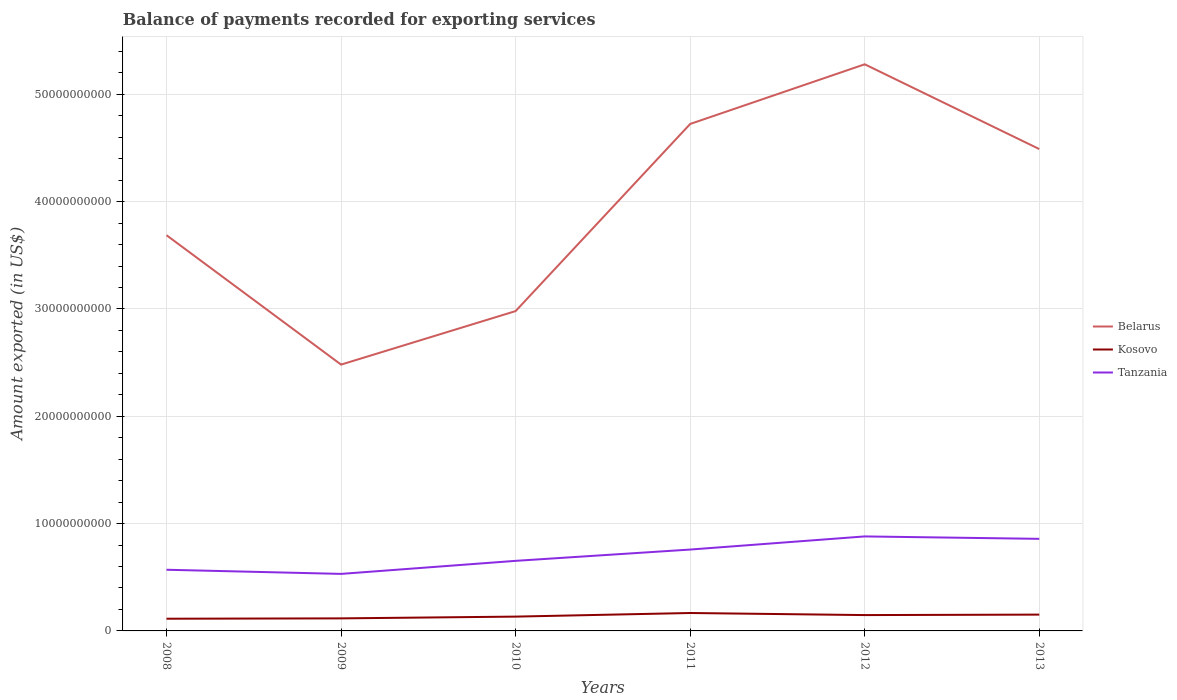Is the number of lines equal to the number of legend labels?
Ensure brevity in your answer.  Yes. Across all years, what is the maximum amount exported in Kosovo?
Ensure brevity in your answer.  1.14e+09. In which year was the amount exported in Kosovo maximum?
Your answer should be very brief. 2008. What is the total amount exported in Belarus in the graph?
Provide a succinct answer. 2.34e+09. What is the difference between the highest and the second highest amount exported in Kosovo?
Make the answer very short. 5.33e+08. What is the difference between the highest and the lowest amount exported in Kosovo?
Ensure brevity in your answer.  3. Is the amount exported in Belarus strictly greater than the amount exported in Tanzania over the years?
Offer a terse response. No. How many lines are there?
Make the answer very short. 3. How many years are there in the graph?
Keep it short and to the point. 6. Does the graph contain any zero values?
Your response must be concise. No. Does the graph contain grids?
Provide a succinct answer. Yes. Where does the legend appear in the graph?
Keep it short and to the point. Center right. How many legend labels are there?
Provide a short and direct response. 3. How are the legend labels stacked?
Offer a very short reply. Vertical. What is the title of the graph?
Your answer should be compact. Balance of payments recorded for exporting services. What is the label or title of the X-axis?
Ensure brevity in your answer.  Years. What is the label or title of the Y-axis?
Your response must be concise. Amount exported (in US$). What is the Amount exported (in US$) in Belarus in 2008?
Ensure brevity in your answer.  3.69e+1. What is the Amount exported (in US$) in Kosovo in 2008?
Provide a short and direct response. 1.14e+09. What is the Amount exported (in US$) of Tanzania in 2008?
Your answer should be very brief. 5.70e+09. What is the Amount exported (in US$) in Belarus in 2009?
Provide a succinct answer. 2.48e+1. What is the Amount exported (in US$) in Kosovo in 2009?
Make the answer very short. 1.17e+09. What is the Amount exported (in US$) in Tanzania in 2009?
Offer a terse response. 5.31e+09. What is the Amount exported (in US$) in Belarus in 2010?
Your answer should be very brief. 2.98e+1. What is the Amount exported (in US$) of Kosovo in 2010?
Offer a terse response. 1.33e+09. What is the Amount exported (in US$) in Tanzania in 2010?
Provide a short and direct response. 6.53e+09. What is the Amount exported (in US$) in Belarus in 2011?
Provide a short and direct response. 4.72e+1. What is the Amount exported (in US$) in Kosovo in 2011?
Your answer should be compact. 1.67e+09. What is the Amount exported (in US$) of Tanzania in 2011?
Provide a short and direct response. 7.58e+09. What is the Amount exported (in US$) in Belarus in 2012?
Keep it short and to the point. 5.28e+1. What is the Amount exported (in US$) in Kosovo in 2012?
Offer a very short reply. 1.48e+09. What is the Amount exported (in US$) of Tanzania in 2012?
Offer a terse response. 8.81e+09. What is the Amount exported (in US$) in Belarus in 2013?
Ensure brevity in your answer.  4.49e+1. What is the Amount exported (in US$) in Kosovo in 2013?
Ensure brevity in your answer.  1.52e+09. What is the Amount exported (in US$) of Tanzania in 2013?
Ensure brevity in your answer.  8.58e+09. Across all years, what is the maximum Amount exported (in US$) of Belarus?
Your answer should be very brief. 5.28e+1. Across all years, what is the maximum Amount exported (in US$) of Kosovo?
Your response must be concise. 1.67e+09. Across all years, what is the maximum Amount exported (in US$) in Tanzania?
Your answer should be compact. 8.81e+09. Across all years, what is the minimum Amount exported (in US$) of Belarus?
Offer a very short reply. 2.48e+1. Across all years, what is the minimum Amount exported (in US$) of Kosovo?
Make the answer very short. 1.14e+09. Across all years, what is the minimum Amount exported (in US$) in Tanzania?
Make the answer very short. 5.31e+09. What is the total Amount exported (in US$) in Belarus in the graph?
Your answer should be compact. 2.36e+11. What is the total Amount exported (in US$) of Kosovo in the graph?
Make the answer very short. 8.31e+09. What is the total Amount exported (in US$) in Tanzania in the graph?
Offer a very short reply. 4.25e+1. What is the difference between the Amount exported (in US$) in Belarus in 2008 and that in 2009?
Your response must be concise. 1.21e+1. What is the difference between the Amount exported (in US$) of Kosovo in 2008 and that in 2009?
Ensure brevity in your answer.  -3.21e+07. What is the difference between the Amount exported (in US$) of Tanzania in 2008 and that in 2009?
Make the answer very short. 3.86e+08. What is the difference between the Amount exported (in US$) of Belarus in 2008 and that in 2010?
Your answer should be very brief. 7.07e+09. What is the difference between the Amount exported (in US$) of Kosovo in 2008 and that in 2010?
Your response must be concise. -1.95e+08. What is the difference between the Amount exported (in US$) of Tanzania in 2008 and that in 2010?
Provide a succinct answer. -8.30e+08. What is the difference between the Amount exported (in US$) in Belarus in 2008 and that in 2011?
Make the answer very short. -1.04e+1. What is the difference between the Amount exported (in US$) of Kosovo in 2008 and that in 2011?
Your response must be concise. -5.33e+08. What is the difference between the Amount exported (in US$) in Tanzania in 2008 and that in 2011?
Ensure brevity in your answer.  -1.88e+09. What is the difference between the Amount exported (in US$) of Belarus in 2008 and that in 2012?
Give a very brief answer. -1.59e+1. What is the difference between the Amount exported (in US$) in Kosovo in 2008 and that in 2012?
Make the answer very short. -3.39e+08. What is the difference between the Amount exported (in US$) in Tanzania in 2008 and that in 2012?
Your response must be concise. -3.11e+09. What is the difference between the Amount exported (in US$) in Belarus in 2008 and that in 2013?
Give a very brief answer. -8.03e+09. What is the difference between the Amount exported (in US$) in Kosovo in 2008 and that in 2013?
Your response must be concise. -3.82e+08. What is the difference between the Amount exported (in US$) of Tanzania in 2008 and that in 2013?
Provide a short and direct response. -2.88e+09. What is the difference between the Amount exported (in US$) of Belarus in 2009 and that in 2010?
Provide a short and direct response. -4.99e+09. What is the difference between the Amount exported (in US$) of Kosovo in 2009 and that in 2010?
Provide a succinct answer. -1.63e+08. What is the difference between the Amount exported (in US$) of Tanzania in 2009 and that in 2010?
Ensure brevity in your answer.  -1.22e+09. What is the difference between the Amount exported (in US$) in Belarus in 2009 and that in 2011?
Your response must be concise. -2.24e+1. What is the difference between the Amount exported (in US$) of Kosovo in 2009 and that in 2011?
Provide a succinct answer. -5.01e+08. What is the difference between the Amount exported (in US$) in Tanzania in 2009 and that in 2011?
Give a very brief answer. -2.27e+09. What is the difference between the Amount exported (in US$) in Belarus in 2009 and that in 2012?
Your answer should be very brief. -2.80e+1. What is the difference between the Amount exported (in US$) in Kosovo in 2009 and that in 2012?
Your response must be concise. -3.07e+08. What is the difference between the Amount exported (in US$) of Tanzania in 2009 and that in 2012?
Give a very brief answer. -3.49e+09. What is the difference between the Amount exported (in US$) of Belarus in 2009 and that in 2013?
Give a very brief answer. -2.01e+1. What is the difference between the Amount exported (in US$) in Kosovo in 2009 and that in 2013?
Offer a terse response. -3.50e+08. What is the difference between the Amount exported (in US$) in Tanzania in 2009 and that in 2013?
Keep it short and to the point. -3.27e+09. What is the difference between the Amount exported (in US$) of Belarus in 2010 and that in 2011?
Your answer should be compact. -1.74e+1. What is the difference between the Amount exported (in US$) in Kosovo in 2010 and that in 2011?
Your answer should be very brief. -3.37e+08. What is the difference between the Amount exported (in US$) in Tanzania in 2010 and that in 2011?
Provide a succinct answer. -1.05e+09. What is the difference between the Amount exported (in US$) in Belarus in 2010 and that in 2012?
Ensure brevity in your answer.  -2.30e+1. What is the difference between the Amount exported (in US$) of Kosovo in 2010 and that in 2012?
Offer a very short reply. -1.44e+08. What is the difference between the Amount exported (in US$) in Tanzania in 2010 and that in 2012?
Your answer should be compact. -2.28e+09. What is the difference between the Amount exported (in US$) in Belarus in 2010 and that in 2013?
Ensure brevity in your answer.  -1.51e+1. What is the difference between the Amount exported (in US$) of Kosovo in 2010 and that in 2013?
Give a very brief answer. -1.87e+08. What is the difference between the Amount exported (in US$) of Tanzania in 2010 and that in 2013?
Your answer should be compact. -2.05e+09. What is the difference between the Amount exported (in US$) of Belarus in 2011 and that in 2012?
Your answer should be compact. -5.56e+09. What is the difference between the Amount exported (in US$) of Kosovo in 2011 and that in 2012?
Your answer should be very brief. 1.93e+08. What is the difference between the Amount exported (in US$) of Tanzania in 2011 and that in 2012?
Make the answer very short. -1.22e+09. What is the difference between the Amount exported (in US$) of Belarus in 2011 and that in 2013?
Ensure brevity in your answer.  2.34e+09. What is the difference between the Amount exported (in US$) of Kosovo in 2011 and that in 2013?
Make the answer very short. 1.50e+08. What is the difference between the Amount exported (in US$) of Tanzania in 2011 and that in 2013?
Provide a succinct answer. -9.98e+08. What is the difference between the Amount exported (in US$) in Belarus in 2012 and that in 2013?
Ensure brevity in your answer.  7.90e+09. What is the difference between the Amount exported (in US$) of Kosovo in 2012 and that in 2013?
Your answer should be compact. -4.29e+07. What is the difference between the Amount exported (in US$) in Tanzania in 2012 and that in 2013?
Ensure brevity in your answer.  2.26e+08. What is the difference between the Amount exported (in US$) in Belarus in 2008 and the Amount exported (in US$) in Kosovo in 2009?
Offer a very short reply. 3.57e+1. What is the difference between the Amount exported (in US$) in Belarus in 2008 and the Amount exported (in US$) in Tanzania in 2009?
Ensure brevity in your answer.  3.16e+1. What is the difference between the Amount exported (in US$) of Kosovo in 2008 and the Amount exported (in US$) of Tanzania in 2009?
Provide a succinct answer. -4.18e+09. What is the difference between the Amount exported (in US$) in Belarus in 2008 and the Amount exported (in US$) in Kosovo in 2010?
Offer a very short reply. 3.55e+1. What is the difference between the Amount exported (in US$) in Belarus in 2008 and the Amount exported (in US$) in Tanzania in 2010?
Provide a short and direct response. 3.03e+1. What is the difference between the Amount exported (in US$) in Kosovo in 2008 and the Amount exported (in US$) in Tanzania in 2010?
Provide a succinct answer. -5.39e+09. What is the difference between the Amount exported (in US$) of Belarus in 2008 and the Amount exported (in US$) of Kosovo in 2011?
Make the answer very short. 3.52e+1. What is the difference between the Amount exported (in US$) in Belarus in 2008 and the Amount exported (in US$) in Tanzania in 2011?
Your answer should be very brief. 2.93e+1. What is the difference between the Amount exported (in US$) of Kosovo in 2008 and the Amount exported (in US$) of Tanzania in 2011?
Your answer should be compact. -6.44e+09. What is the difference between the Amount exported (in US$) of Belarus in 2008 and the Amount exported (in US$) of Kosovo in 2012?
Make the answer very short. 3.54e+1. What is the difference between the Amount exported (in US$) in Belarus in 2008 and the Amount exported (in US$) in Tanzania in 2012?
Give a very brief answer. 2.81e+1. What is the difference between the Amount exported (in US$) in Kosovo in 2008 and the Amount exported (in US$) in Tanzania in 2012?
Provide a short and direct response. -7.67e+09. What is the difference between the Amount exported (in US$) in Belarus in 2008 and the Amount exported (in US$) in Kosovo in 2013?
Make the answer very short. 3.54e+1. What is the difference between the Amount exported (in US$) of Belarus in 2008 and the Amount exported (in US$) of Tanzania in 2013?
Keep it short and to the point. 2.83e+1. What is the difference between the Amount exported (in US$) of Kosovo in 2008 and the Amount exported (in US$) of Tanzania in 2013?
Provide a short and direct response. -7.44e+09. What is the difference between the Amount exported (in US$) of Belarus in 2009 and the Amount exported (in US$) of Kosovo in 2010?
Make the answer very short. 2.35e+1. What is the difference between the Amount exported (in US$) in Belarus in 2009 and the Amount exported (in US$) in Tanzania in 2010?
Offer a very short reply. 1.83e+1. What is the difference between the Amount exported (in US$) of Kosovo in 2009 and the Amount exported (in US$) of Tanzania in 2010?
Offer a terse response. -5.36e+09. What is the difference between the Amount exported (in US$) of Belarus in 2009 and the Amount exported (in US$) of Kosovo in 2011?
Give a very brief answer. 2.31e+1. What is the difference between the Amount exported (in US$) of Belarus in 2009 and the Amount exported (in US$) of Tanzania in 2011?
Ensure brevity in your answer.  1.72e+1. What is the difference between the Amount exported (in US$) in Kosovo in 2009 and the Amount exported (in US$) in Tanzania in 2011?
Keep it short and to the point. -6.41e+09. What is the difference between the Amount exported (in US$) in Belarus in 2009 and the Amount exported (in US$) in Kosovo in 2012?
Your answer should be very brief. 2.33e+1. What is the difference between the Amount exported (in US$) of Belarus in 2009 and the Amount exported (in US$) of Tanzania in 2012?
Ensure brevity in your answer.  1.60e+1. What is the difference between the Amount exported (in US$) in Kosovo in 2009 and the Amount exported (in US$) in Tanzania in 2012?
Give a very brief answer. -7.64e+09. What is the difference between the Amount exported (in US$) in Belarus in 2009 and the Amount exported (in US$) in Kosovo in 2013?
Ensure brevity in your answer.  2.33e+1. What is the difference between the Amount exported (in US$) of Belarus in 2009 and the Amount exported (in US$) of Tanzania in 2013?
Provide a succinct answer. 1.62e+1. What is the difference between the Amount exported (in US$) in Kosovo in 2009 and the Amount exported (in US$) in Tanzania in 2013?
Your response must be concise. -7.41e+09. What is the difference between the Amount exported (in US$) of Belarus in 2010 and the Amount exported (in US$) of Kosovo in 2011?
Make the answer very short. 2.81e+1. What is the difference between the Amount exported (in US$) in Belarus in 2010 and the Amount exported (in US$) in Tanzania in 2011?
Your answer should be compact. 2.22e+1. What is the difference between the Amount exported (in US$) in Kosovo in 2010 and the Amount exported (in US$) in Tanzania in 2011?
Your answer should be compact. -6.25e+09. What is the difference between the Amount exported (in US$) in Belarus in 2010 and the Amount exported (in US$) in Kosovo in 2012?
Give a very brief answer. 2.83e+1. What is the difference between the Amount exported (in US$) of Belarus in 2010 and the Amount exported (in US$) of Tanzania in 2012?
Your answer should be compact. 2.10e+1. What is the difference between the Amount exported (in US$) of Kosovo in 2010 and the Amount exported (in US$) of Tanzania in 2012?
Make the answer very short. -7.47e+09. What is the difference between the Amount exported (in US$) in Belarus in 2010 and the Amount exported (in US$) in Kosovo in 2013?
Your answer should be very brief. 2.83e+1. What is the difference between the Amount exported (in US$) of Belarus in 2010 and the Amount exported (in US$) of Tanzania in 2013?
Offer a terse response. 2.12e+1. What is the difference between the Amount exported (in US$) in Kosovo in 2010 and the Amount exported (in US$) in Tanzania in 2013?
Offer a terse response. -7.25e+09. What is the difference between the Amount exported (in US$) in Belarus in 2011 and the Amount exported (in US$) in Kosovo in 2012?
Your response must be concise. 4.58e+1. What is the difference between the Amount exported (in US$) in Belarus in 2011 and the Amount exported (in US$) in Tanzania in 2012?
Ensure brevity in your answer.  3.84e+1. What is the difference between the Amount exported (in US$) of Kosovo in 2011 and the Amount exported (in US$) of Tanzania in 2012?
Keep it short and to the point. -7.14e+09. What is the difference between the Amount exported (in US$) in Belarus in 2011 and the Amount exported (in US$) in Kosovo in 2013?
Offer a very short reply. 4.57e+1. What is the difference between the Amount exported (in US$) in Belarus in 2011 and the Amount exported (in US$) in Tanzania in 2013?
Offer a terse response. 3.87e+1. What is the difference between the Amount exported (in US$) of Kosovo in 2011 and the Amount exported (in US$) of Tanzania in 2013?
Your response must be concise. -6.91e+09. What is the difference between the Amount exported (in US$) of Belarus in 2012 and the Amount exported (in US$) of Kosovo in 2013?
Make the answer very short. 5.13e+1. What is the difference between the Amount exported (in US$) of Belarus in 2012 and the Amount exported (in US$) of Tanzania in 2013?
Your response must be concise. 4.42e+1. What is the difference between the Amount exported (in US$) in Kosovo in 2012 and the Amount exported (in US$) in Tanzania in 2013?
Your response must be concise. -7.10e+09. What is the average Amount exported (in US$) in Belarus per year?
Make the answer very short. 3.94e+1. What is the average Amount exported (in US$) in Kosovo per year?
Your answer should be compact. 1.38e+09. What is the average Amount exported (in US$) of Tanzania per year?
Your answer should be compact. 7.09e+09. In the year 2008, what is the difference between the Amount exported (in US$) in Belarus and Amount exported (in US$) in Kosovo?
Provide a succinct answer. 3.57e+1. In the year 2008, what is the difference between the Amount exported (in US$) of Belarus and Amount exported (in US$) of Tanzania?
Provide a succinct answer. 3.12e+1. In the year 2008, what is the difference between the Amount exported (in US$) of Kosovo and Amount exported (in US$) of Tanzania?
Offer a terse response. -4.56e+09. In the year 2009, what is the difference between the Amount exported (in US$) of Belarus and Amount exported (in US$) of Kosovo?
Provide a succinct answer. 2.36e+1. In the year 2009, what is the difference between the Amount exported (in US$) in Belarus and Amount exported (in US$) in Tanzania?
Offer a very short reply. 1.95e+1. In the year 2009, what is the difference between the Amount exported (in US$) in Kosovo and Amount exported (in US$) in Tanzania?
Make the answer very short. -4.14e+09. In the year 2010, what is the difference between the Amount exported (in US$) in Belarus and Amount exported (in US$) in Kosovo?
Give a very brief answer. 2.85e+1. In the year 2010, what is the difference between the Amount exported (in US$) of Belarus and Amount exported (in US$) of Tanzania?
Ensure brevity in your answer.  2.33e+1. In the year 2010, what is the difference between the Amount exported (in US$) of Kosovo and Amount exported (in US$) of Tanzania?
Ensure brevity in your answer.  -5.20e+09. In the year 2011, what is the difference between the Amount exported (in US$) of Belarus and Amount exported (in US$) of Kosovo?
Make the answer very short. 4.56e+1. In the year 2011, what is the difference between the Amount exported (in US$) in Belarus and Amount exported (in US$) in Tanzania?
Provide a short and direct response. 3.97e+1. In the year 2011, what is the difference between the Amount exported (in US$) in Kosovo and Amount exported (in US$) in Tanzania?
Offer a very short reply. -5.91e+09. In the year 2012, what is the difference between the Amount exported (in US$) of Belarus and Amount exported (in US$) of Kosovo?
Keep it short and to the point. 5.13e+1. In the year 2012, what is the difference between the Amount exported (in US$) of Belarus and Amount exported (in US$) of Tanzania?
Your answer should be compact. 4.40e+1. In the year 2012, what is the difference between the Amount exported (in US$) of Kosovo and Amount exported (in US$) of Tanzania?
Offer a very short reply. -7.33e+09. In the year 2013, what is the difference between the Amount exported (in US$) of Belarus and Amount exported (in US$) of Kosovo?
Offer a very short reply. 4.34e+1. In the year 2013, what is the difference between the Amount exported (in US$) in Belarus and Amount exported (in US$) in Tanzania?
Your response must be concise. 3.63e+1. In the year 2013, what is the difference between the Amount exported (in US$) of Kosovo and Amount exported (in US$) of Tanzania?
Offer a terse response. -7.06e+09. What is the ratio of the Amount exported (in US$) in Belarus in 2008 to that in 2009?
Offer a very short reply. 1.49. What is the ratio of the Amount exported (in US$) of Kosovo in 2008 to that in 2009?
Keep it short and to the point. 0.97. What is the ratio of the Amount exported (in US$) in Tanzania in 2008 to that in 2009?
Offer a very short reply. 1.07. What is the ratio of the Amount exported (in US$) in Belarus in 2008 to that in 2010?
Provide a short and direct response. 1.24. What is the ratio of the Amount exported (in US$) in Kosovo in 2008 to that in 2010?
Offer a very short reply. 0.85. What is the ratio of the Amount exported (in US$) in Tanzania in 2008 to that in 2010?
Offer a very short reply. 0.87. What is the ratio of the Amount exported (in US$) of Belarus in 2008 to that in 2011?
Provide a short and direct response. 0.78. What is the ratio of the Amount exported (in US$) in Kosovo in 2008 to that in 2011?
Provide a succinct answer. 0.68. What is the ratio of the Amount exported (in US$) of Tanzania in 2008 to that in 2011?
Offer a terse response. 0.75. What is the ratio of the Amount exported (in US$) of Belarus in 2008 to that in 2012?
Offer a very short reply. 0.7. What is the ratio of the Amount exported (in US$) in Kosovo in 2008 to that in 2012?
Keep it short and to the point. 0.77. What is the ratio of the Amount exported (in US$) of Tanzania in 2008 to that in 2012?
Your response must be concise. 0.65. What is the ratio of the Amount exported (in US$) of Belarus in 2008 to that in 2013?
Offer a terse response. 0.82. What is the ratio of the Amount exported (in US$) in Kosovo in 2008 to that in 2013?
Your answer should be compact. 0.75. What is the ratio of the Amount exported (in US$) of Tanzania in 2008 to that in 2013?
Your answer should be compact. 0.66. What is the ratio of the Amount exported (in US$) of Belarus in 2009 to that in 2010?
Provide a short and direct response. 0.83. What is the ratio of the Amount exported (in US$) of Kosovo in 2009 to that in 2010?
Offer a terse response. 0.88. What is the ratio of the Amount exported (in US$) of Tanzania in 2009 to that in 2010?
Your response must be concise. 0.81. What is the ratio of the Amount exported (in US$) in Belarus in 2009 to that in 2011?
Make the answer very short. 0.53. What is the ratio of the Amount exported (in US$) of Kosovo in 2009 to that in 2011?
Your response must be concise. 0.7. What is the ratio of the Amount exported (in US$) of Tanzania in 2009 to that in 2011?
Your answer should be very brief. 0.7. What is the ratio of the Amount exported (in US$) of Belarus in 2009 to that in 2012?
Offer a terse response. 0.47. What is the ratio of the Amount exported (in US$) in Kosovo in 2009 to that in 2012?
Your answer should be compact. 0.79. What is the ratio of the Amount exported (in US$) of Tanzania in 2009 to that in 2012?
Your answer should be very brief. 0.6. What is the ratio of the Amount exported (in US$) of Belarus in 2009 to that in 2013?
Provide a succinct answer. 0.55. What is the ratio of the Amount exported (in US$) in Kosovo in 2009 to that in 2013?
Your answer should be compact. 0.77. What is the ratio of the Amount exported (in US$) in Tanzania in 2009 to that in 2013?
Your answer should be compact. 0.62. What is the ratio of the Amount exported (in US$) in Belarus in 2010 to that in 2011?
Give a very brief answer. 0.63. What is the ratio of the Amount exported (in US$) in Kosovo in 2010 to that in 2011?
Make the answer very short. 0.8. What is the ratio of the Amount exported (in US$) of Tanzania in 2010 to that in 2011?
Keep it short and to the point. 0.86. What is the ratio of the Amount exported (in US$) of Belarus in 2010 to that in 2012?
Provide a succinct answer. 0.56. What is the ratio of the Amount exported (in US$) in Kosovo in 2010 to that in 2012?
Ensure brevity in your answer.  0.9. What is the ratio of the Amount exported (in US$) of Tanzania in 2010 to that in 2012?
Offer a very short reply. 0.74. What is the ratio of the Amount exported (in US$) of Belarus in 2010 to that in 2013?
Provide a short and direct response. 0.66. What is the ratio of the Amount exported (in US$) in Kosovo in 2010 to that in 2013?
Offer a very short reply. 0.88. What is the ratio of the Amount exported (in US$) of Tanzania in 2010 to that in 2013?
Your response must be concise. 0.76. What is the ratio of the Amount exported (in US$) in Belarus in 2011 to that in 2012?
Provide a short and direct response. 0.89. What is the ratio of the Amount exported (in US$) of Kosovo in 2011 to that in 2012?
Make the answer very short. 1.13. What is the ratio of the Amount exported (in US$) in Tanzania in 2011 to that in 2012?
Your answer should be compact. 0.86. What is the ratio of the Amount exported (in US$) of Belarus in 2011 to that in 2013?
Your answer should be compact. 1.05. What is the ratio of the Amount exported (in US$) of Kosovo in 2011 to that in 2013?
Your response must be concise. 1.1. What is the ratio of the Amount exported (in US$) of Tanzania in 2011 to that in 2013?
Provide a succinct answer. 0.88. What is the ratio of the Amount exported (in US$) of Belarus in 2012 to that in 2013?
Provide a succinct answer. 1.18. What is the ratio of the Amount exported (in US$) in Kosovo in 2012 to that in 2013?
Provide a short and direct response. 0.97. What is the ratio of the Amount exported (in US$) in Tanzania in 2012 to that in 2013?
Provide a short and direct response. 1.03. What is the difference between the highest and the second highest Amount exported (in US$) of Belarus?
Provide a succinct answer. 5.56e+09. What is the difference between the highest and the second highest Amount exported (in US$) in Kosovo?
Your answer should be compact. 1.50e+08. What is the difference between the highest and the second highest Amount exported (in US$) of Tanzania?
Your response must be concise. 2.26e+08. What is the difference between the highest and the lowest Amount exported (in US$) of Belarus?
Provide a short and direct response. 2.80e+1. What is the difference between the highest and the lowest Amount exported (in US$) of Kosovo?
Offer a very short reply. 5.33e+08. What is the difference between the highest and the lowest Amount exported (in US$) in Tanzania?
Make the answer very short. 3.49e+09. 